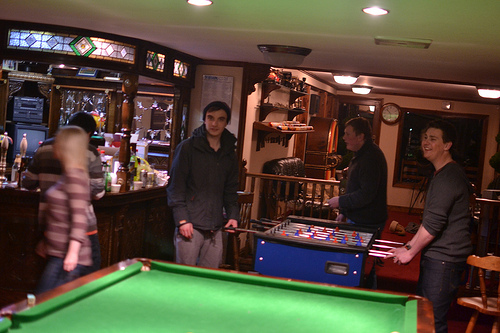<image>
Is the pool table behind the woman? Yes. From this viewpoint, the pool table is positioned behind the woman, with the woman partially or fully occluding the pool table. 